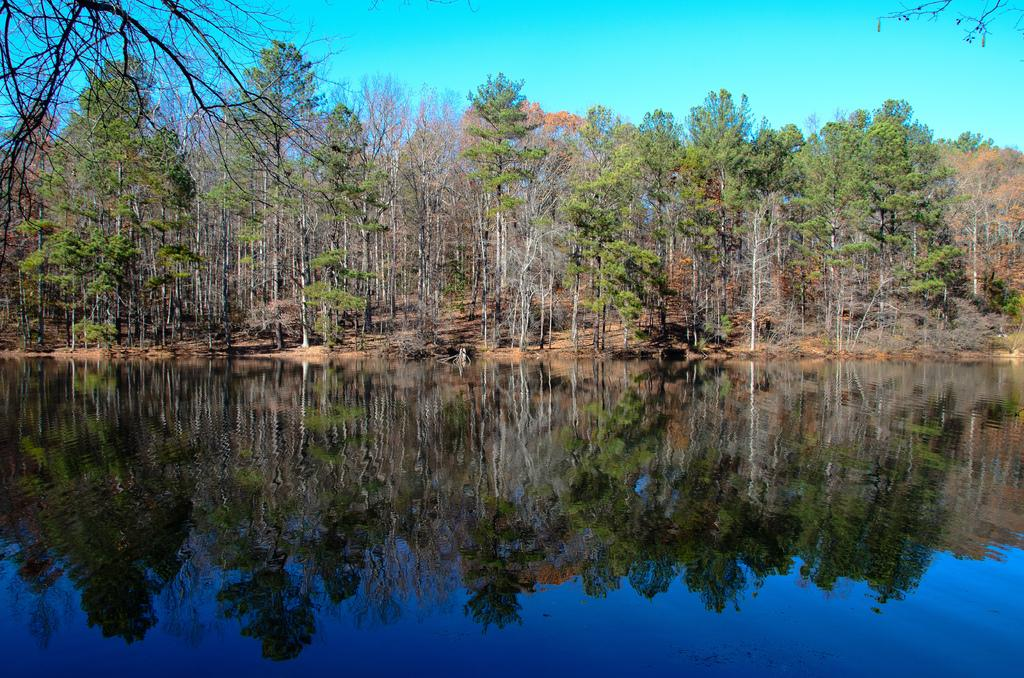What type of vegetation is present on the ground in the image? There are trees on the ground in the image. What natural element can be seen besides the trees? There is water visible in the image. What is visible in the background of the image? The sky is visible in the background of the image. Can you see any giraffes in the image? No, there are no giraffes present in the image. What type of lumber is being used to construct the trees in the image? The trees in the image are natural, living organisms and do not require lumber for construction. 